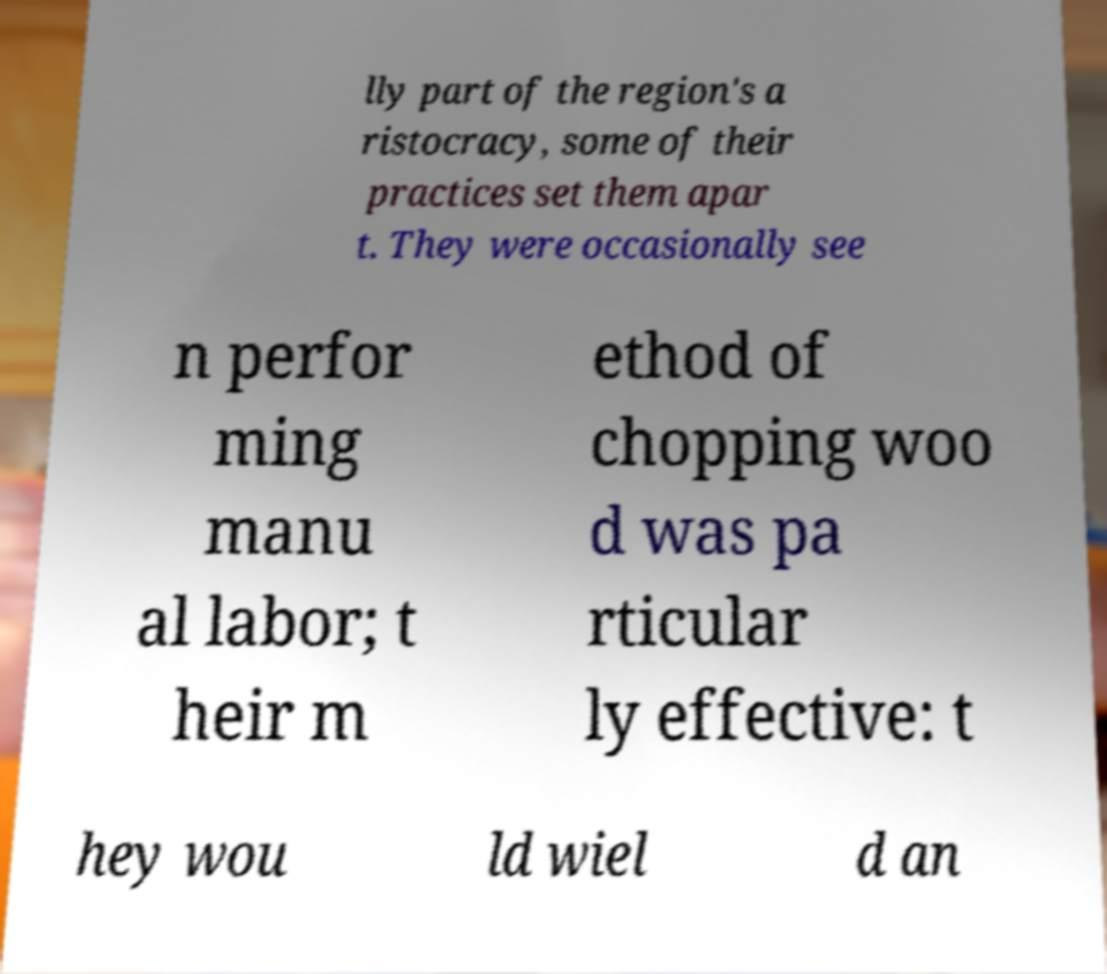What messages or text are displayed in this image? I need them in a readable, typed format. lly part of the region's a ristocracy, some of their practices set them apar t. They were occasionally see n perfor ming manu al labor; t heir m ethod of chopping woo d was pa rticular ly effective: t hey wou ld wiel d an 